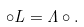<formula> <loc_0><loc_0><loc_500><loc_500>\circ L = \Lambda \circ .</formula> 